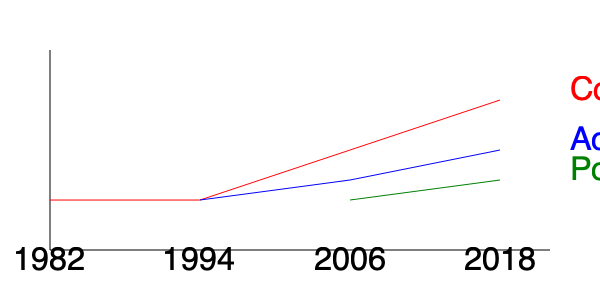Based on the timeline graph of Eddie Izzard's career transitions, in which year did Izzard's involvement in politics begin to gain prominence, and how did this impact the trajectory of their comedy career? To answer this question, let's analyze the graph step-by-step:

1. The graph shows three career paths for Eddie Izzard: Comedy (red), Acting (blue), and Politics (green).

2. The timeline spans from 1982 to 2018, divided into four points: 1982, 1994, 2006, and 2018.

3. Comedy (red line):
   - Starts in 1982 at a high point
   - Remains constant until 1994
   - Gradually declines from 1994 to 2018

4. Acting (blue line):
   - Begins around 1994
   - Rises slightly until 2006
   - Continues to rise more steeply from 2006 to 2018

5. Politics (green line):
   - Starts around 2006
   - Gradually rises from 2006 to 2018

6. The question asks about the year Izzard's political involvement gained prominence:
   - The political career line (green) begins in 2006

7. Impact on comedy career:
   - From 2006 onwards, the comedy line (red) shows a steeper decline
   - This coincides with the rise of both the political and acting career lines

Therefore, Eddie Izzard's involvement in politics began to gain prominence in 2006. This coincided with a more noticeable decline in their comedy career trajectory, suggesting that as Izzard became more involved in politics (and acting), they reduced their focus on stand-up comedy.
Answer: 2006; comedy career declined more noticeably 